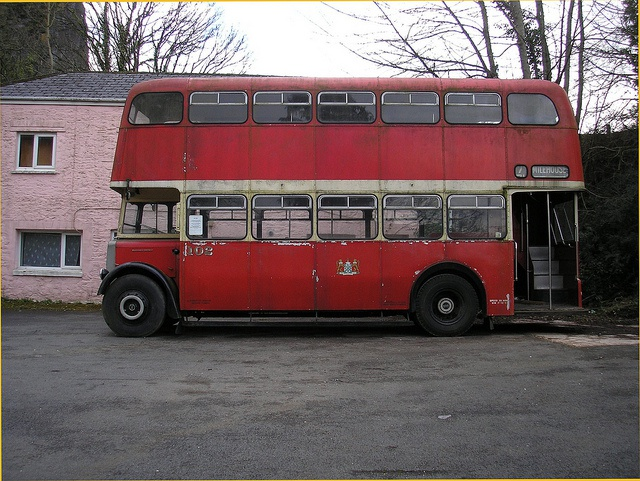Describe the objects in this image and their specific colors. I can see bus in orange, black, brown, gray, and maroon tones in this image. 